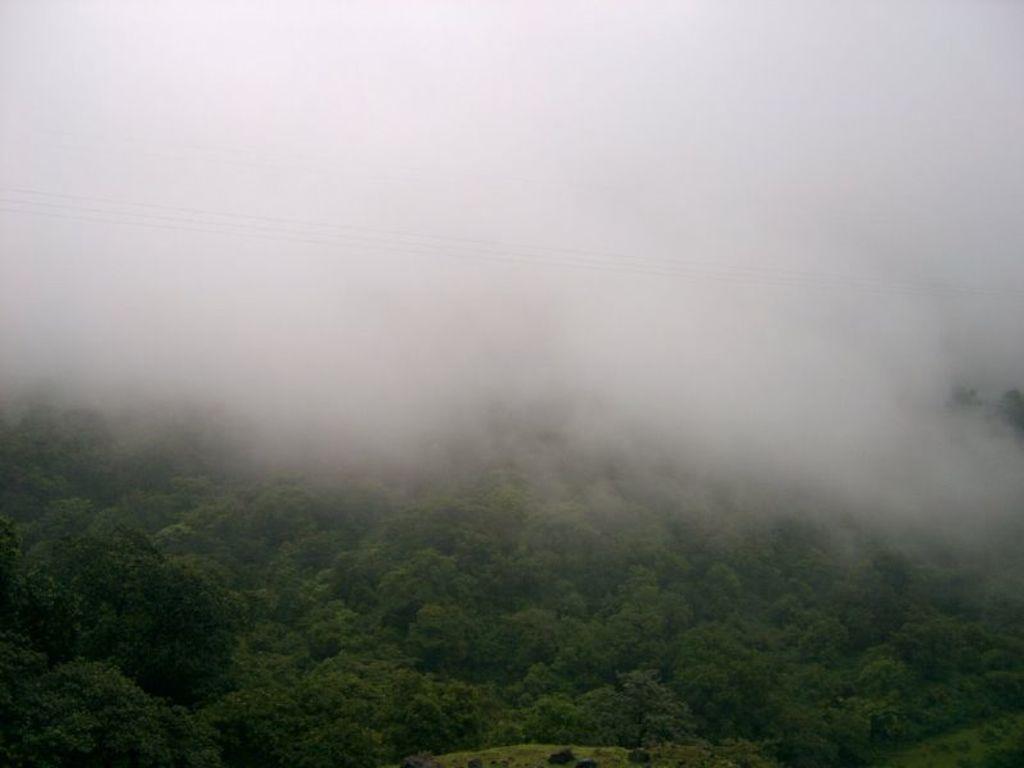Can you describe this image briefly? In the down side there are green color trees. At the top it's a foggy foggy. 